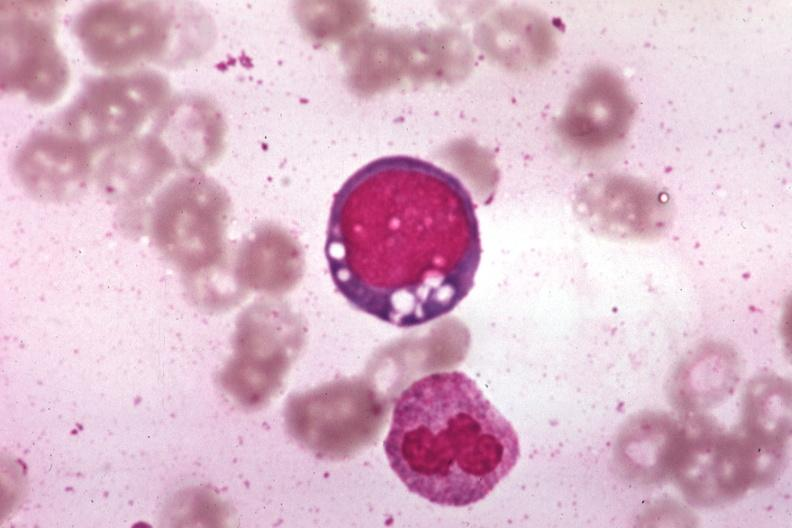s hematologic present?
Answer the question using a single word or phrase. Yes 